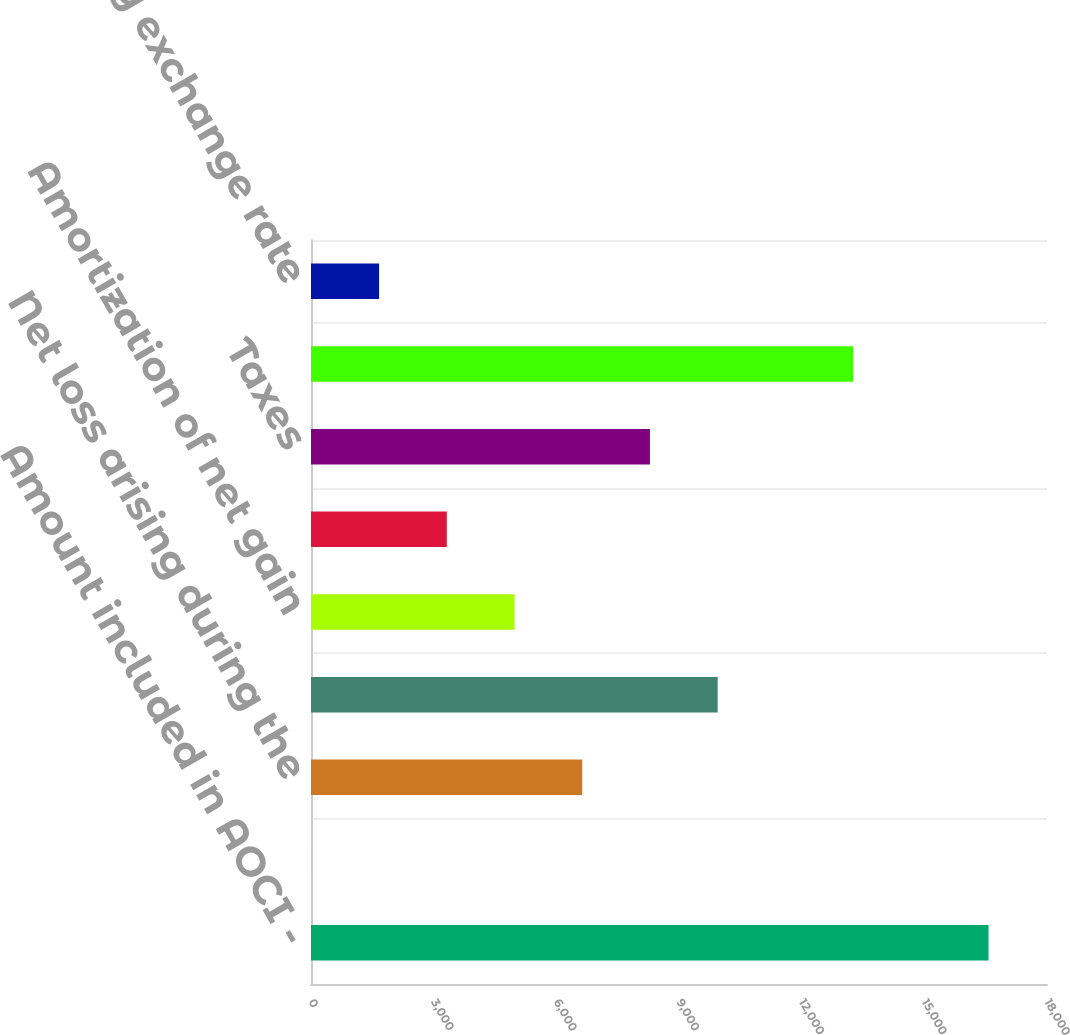<chart> <loc_0><loc_0><loc_500><loc_500><bar_chart><fcel>Amount included in AOCI -<fcel>Prior service cost<fcel>Net loss arising during the<fcel>Change in assumptions<fcel>Amortization of net gain<fcel>Plan assets losses<fcel>Taxes<fcel>Curtailment<fcel>Foreign currency exchange rate<nl><fcel>16570<fcel>9<fcel>6633.4<fcel>9945.6<fcel>4977.3<fcel>3321.2<fcel>8289.5<fcel>13257.8<fcel>1665.1<nl></chart> 